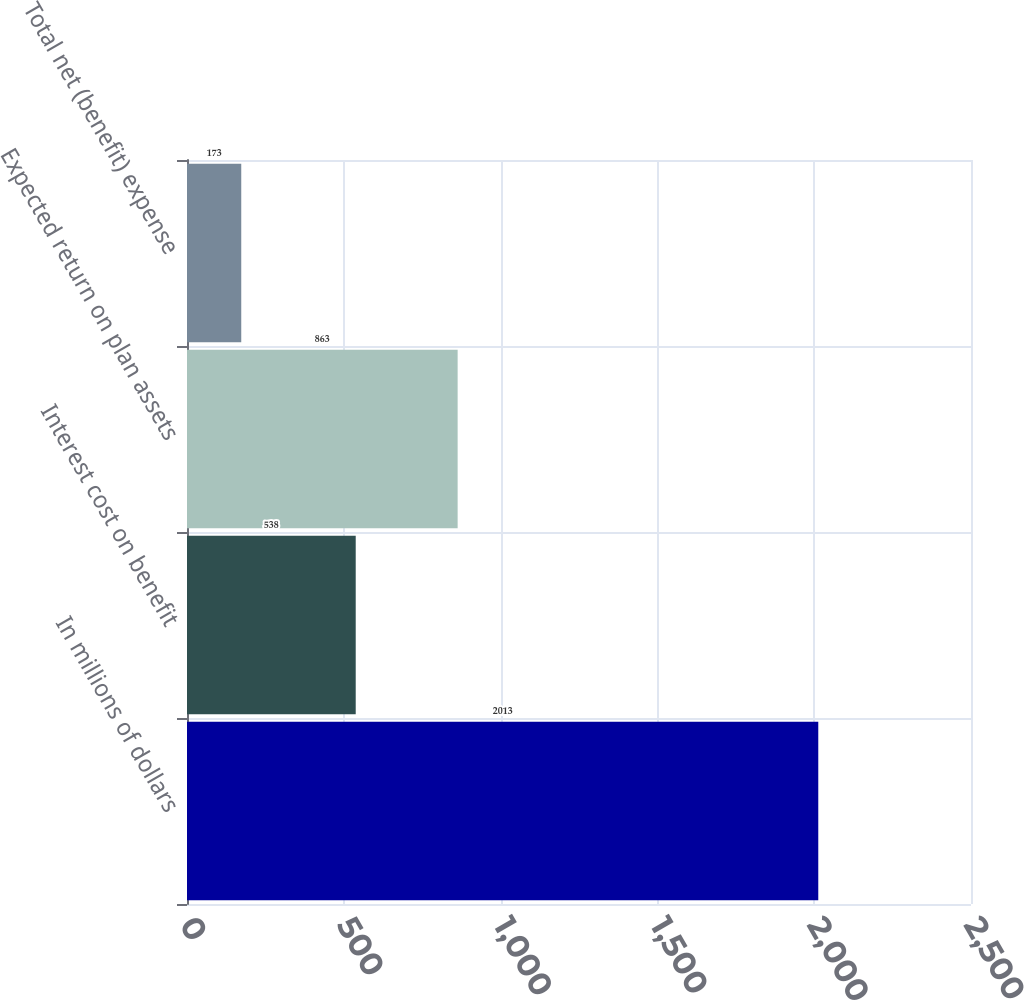Convert chart to OTSL. <chart><loc_0><loc_0><loc_500><loc_500><bar_chart><fcel>In millions of dollars<fcel>Interest cost on benefit<fcel>Expected return on plan assets<fcel>Total net (benefit) expense<nl><fcel>2013<fcel>538<fcel>863<fcel>173<nl></chart> 